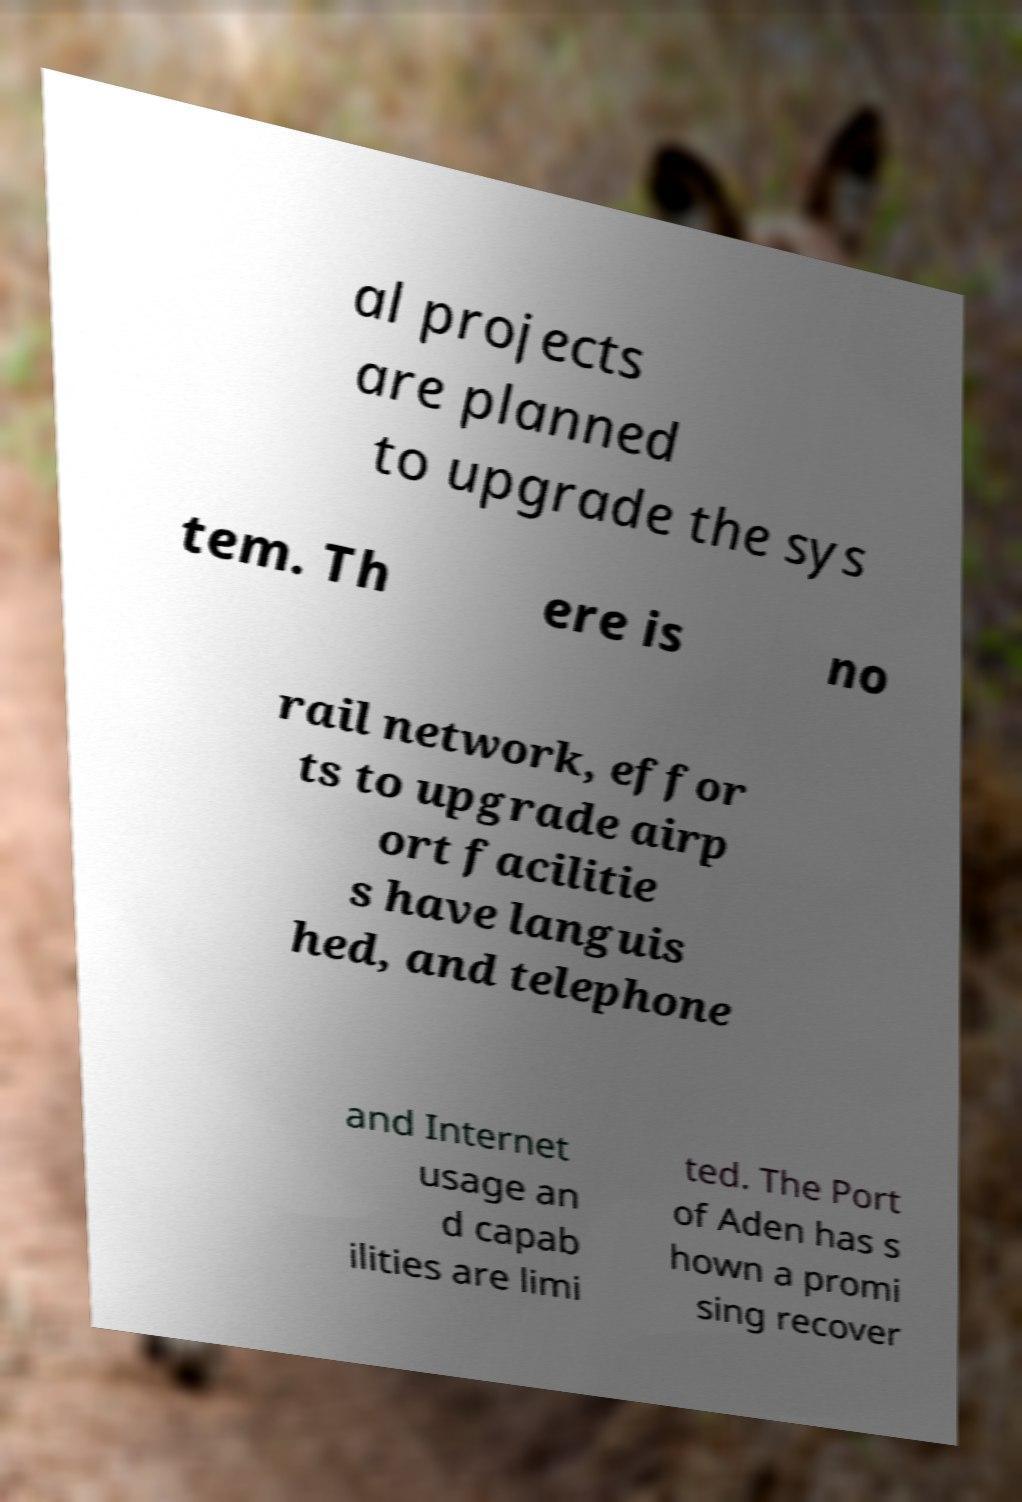Can you read and provide the text displayed in the image?This photo seems to have some interesting text. Can you extract and type it out for me? al projects are planned to upgrade the sys tem. Th ere is no rail network, effor ts to upgrade airp ort facilitie s have languis hed, and telephone and Internet usage an d capab ilities are limi ted. The Port of Aden has s hown a promi sing recover 